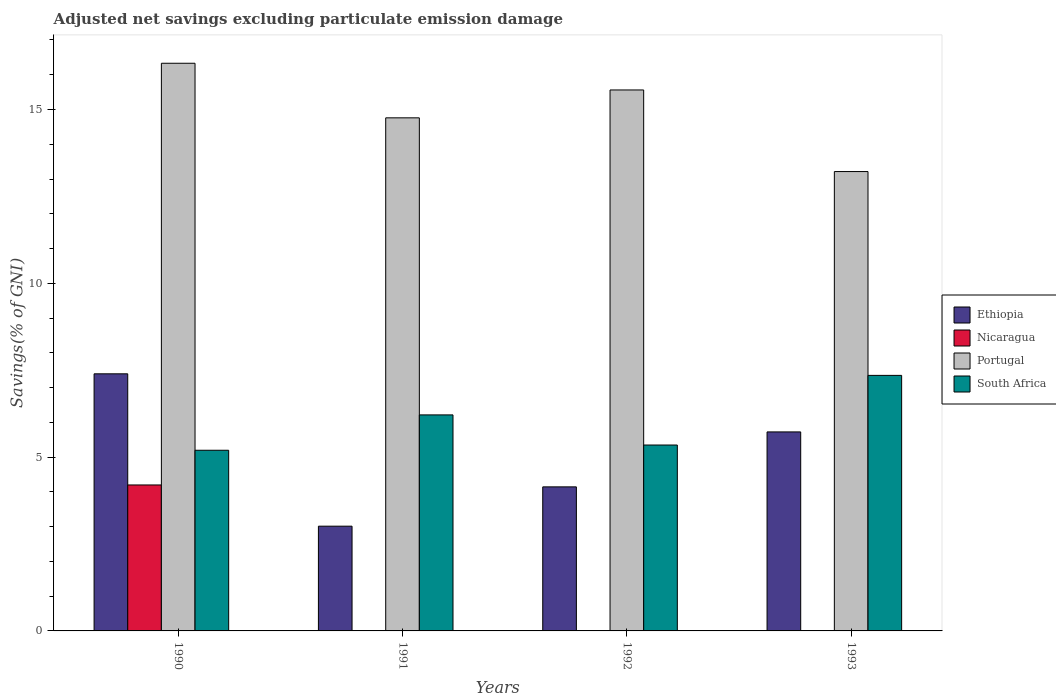How many groups of bars are there?
Make the answer very short. 4. How many bars are there on the 1st tick from the left?
Offer a very short reply. 4. What is the label of the 2nd group of bars from the left?
Ensure brevity in your answer.  1991. In how many cases, is the number of bars for a given year not equal to the number of legend labels?
Offer a terse response. 3. What is the adjusted net savings in Ethiopia in 1993?
Offer a very short reply. 5.72. Across all years, what is the maximum adjusted net savings in Portugal?
Make the answer very short. 16.33. Across all years, what is the minimum adjusted net savings in Portugal?
Offer a very short reply. 13.21. What is the total adjusted net savings in Nicaragua in the graph?
Offer a very short reply. 4.2. What is the difference between the adjusted net savings in Portugal in 1990 and that in 1993?
Provide a succinct answer. 3.12. What is the difference between the adjusted net savings in Nicaragua in 1993 and the adjusted net savings in South Africa in 1991?
Provide a short and direct response. -6.21. What is the average adjusted net savings in Nicaragua per year?
Give a very brief answer. 1.05. In the year 1990, what is the difference between the adjusted net savings in Nicaragua and adjusted net savings in Portugal?
Offer a very short reply. -12.13. What is the ratio of the adjusted net savings in Ethiopia in 1991 to that in 1993?
Your answer should be very brief. 0.53. What is the difference between the highest and the second highest adjusted net savings in Ethiopia?
Your answer should be very brief. 1.67. What is the difference between the highest and the lowest adjusted net savings in Ethiopia?
Ensure brevity in your answer.  4.38. Is it the case that in every year, the sum of the adjusted net savings in Nicaragua and adjusted net savings in South Africa is greater than the sum of adjusted net savings in Ethiopia and adjusted net savings in Portugal?
Keep it short and to the point. No. Is it the case that in every year, the sum of the adjusted net savings in South Africa and adjusted net savings in Portugal is greater than the adjusted net savings in Ethiopia?
Ensure brevity in your answer.  Yes. How many years are there in the graph?
Provide a short and direct response. 4. Are the values on the major ticks of Y-axis written in scientific E-notation?
Provide a short and direct response. No. Does the graph contain any zero values?
Give a very brief answer. Yes. Does the graph contain grids?
Give a very brief answer. No. How are the legend labels stacked?
Give a very brief answer. Vertical. What is the title of the graph?
Offer a terse response. Adjusted net savings excluding particulate emission damage. Does "Lebanon" appear as one of the legend labels in the graph?
Provide a short and direct response. No. What is the label or title of the Y-axis?
Your answer should be compact. Savings(% of GNI). What is the Savings(% of GNI) of Ethiopia in 1990?
Your response must be concise. 7.4. What is the Savings(% of GNI) of Nicaragua in 1990?
Your answer should be compact. 4.2. What is the Savings(% of GNI) in Portugal in 1990?
Offer a terse response. 16.33. What is the Savings(% of GNI) in South Africa in 1990?
Keep it short and to the point. 5.2. What is the Savings(% of GNI) in Ethiopia in 1991?
Provide a short and direct response. 3.01. What is the Savings(% of GNI) of Portugal in 1991?
Your answer should be compact. 14.76. What is the Savings(% of GNI) in South Africa in 1991?
Your response must be concise. 6.21. What is the Savings(% of GNI) of Ethiopia in 1992?
Make the answer very short. 4.14. What is the Savings(% of GNI) of Nicaragua in 1992?
Offer a very short reply. 0. What is the Savings(% of GNI) of Portugal in 1992?
Provide a succinct answer. 15.56. What is the Savings(% of GNI) of South Africa in 1992?
Make the answer very short. 5.35. What is the Savings(% of GNI) of Ethiopia in 1993?
Your answer should be very brief. 5.72. What is the Savings(% of GNI) in Portugal in 1993?
Make the answer very short. 13.21. What is the Savings(% of GNI) in South Africa in 1993?
Your response must be concise. 7.35. Across all years, what is the maximum Savings(% of GNI) in Ethiopia?
Your answer should be compact. 7.4. Across all years, what is the maximum Savings(% of GNI) in Nicaragua?
Give a very brief answer. 4.2. Across all years, what is the maximum Savings(% of GNI) of Portugal?
Provide a succinct answer. 16.33. Across all years, what is the maximum Savings(% of GNI) in South Africa?
Your answer should be compact. 7.35. Across all years, what is the minimum Savings(% of GNI) of Ethiopia?
Provide a succinct answer. 3.01. Across all years, what is the minimum Savings(% of GNI) of Nicaragua?
Offer a terse response. 0. Across all years, what is the minimum Savings(% of GNI) in Portugal?
Provide a succinct answer. 13.21. Across all years, what is the minimum Savings(% of GNI) in South Africa?
Your response must be concise. 5.2. What is the total Savings(% of GNI) in Ethiopia in the graph?
Keep it short and to the point. 20.28. What is the total Savings(% of GNI) in Nicaragua in the graph?
Your answer should be compact. 4.2. What is the total Savings(% of GNI) in Portugal in the graph?
Your answer should be compact. 59.87. What is the total Savings(% of GNI) in South Africa in the graph?
Offer a very short reply. 24.11. What is the difference between the Savings(% of GNI) in Ethiopia in 1990 and that in 1991?
Your answer should be compact. 4.38. What is the difference between the Savings(% of GNI) in Portugal in 1990 and that in 1991?
Offer a very short reply. 1.57. What is the difference between the Savings(% of GNI) of South Africa in 1990 and that in 1991?
Offer a very short reply. -1.02. What is the difference between the Savings(% of GNI) in Ethiopia in 1990 and that in 1992?
Ensure brevity in your answer.  3.25. What is the difference between the Savings(% of GNI) of Portugal in 1990 and that in 1992?
Keep it short and to the point. 0.77. What is the difference between the Savings(% of GNI) of South Africa in 1990 and that in 1992?
Make the answer very short. -0.15. What is the difference between the Savings(% of GNI) of Ethiopia in 1990 and that in 1993?
Your response must be concise. 1.67. What is the difference between the Savings(% of GNI) of Portugal in 1990 and that in 1993?
Offer a terse response. 3.12. What is the difference between the Savings(% of GNI) in South Africa in 1990 and that in 1993?
Make the answer very short. -2.15. What is the difference between the Savings(% of GNI) of Ethiopia in 1991 and that in 1992?
Provide a succinct answer. -1.13. What is the difference between the Savings(% of GNI) in Portugal in 1991 and that in 1992?
Your answer should be very brief. -0.8. What is the difference between the Savings(% of GNI) of South Africa in 1991 and that in 1992?
Your response must be concise. 0.87. What is the difference between the Savings(% of GNI) in Ethiopia in 1991 and that in 1993?
Your response must be concise. -2.71. What is the difference between the Savings(% of GNI) in Portugal in 1991 and that in 1993?
Your answer should be compact. 1.55. What is the difference between the Savings(% of GNI) in South Africa in 1991 and that in 1993?
Offer a terse response. -1.14. What is the difference between the Savings(% of GNI) in Ethiopia in 1992 and that in 1993?
Provide a succinct answer. -1.58. What is the difference between the Savings(% of GNI) of Portugal in 1992 and that in 1993?
Give a very brief answer. 2.35. What is the difference between the Savings(% of GNI) in South Africa in 1992 and that in 1993?
Make the answer very short. -2. What is the difference between the Savings(% of GNI) in Ethiopia in 1990 and the Savings(% of GNI) in Portugal in 1991?
Give a very brief answer. -7.36. What is the difference between the Savings(% of GNI) of Ethiopia in 1990 and the Savings(% of GNI) of South Africa in 1991?
Provide a short and direct response. 1.18. What is the difference between the Savings(% of GNI) of Nicaragua in 1990 and the Savings(% of GNI) of Portugal in 1991?
Make the answer very short. -10.56. What is the difference between the Savings(% of GNI) in Nicaragua in 1990 and the Savings(% of GNI) in South Africa in 1991?
Provide a succinct answer. -2.02. What is the difference between the Savings(% of GNI) of Portugal in 1990 and the Savings(% of GNI) of South Africa in 1991?
Keep it short and to the point. 10.12. What is the difference between the Savings(% of GNI) of Ethiopia in 1990 and the Savings(% of GNI) of Portugal in 1992?
Give a very brief answer. -8.17. What is the difference between the Savings(% of GNI) of Ethiopia in 1990 and the Savings(% of GNI) of South Africa in 1992?
Offer a very short reply. 2.05. What is the difference between the Savings(% of GNI) in Nicaragua in 1990 and the Savings(% of GNI) in Portugal in 1992?
Make the answer very short. -11.36. What is the difference between the Savings(% of GNI) of Nicaragua in 1990 and the Savings(% of GNI) of South Africa in 1992?
Offer a terse response. -1.15. What is the difference between the Savings(% of GNI) of Portugal in 1990 and the Savings(% of GNI) of South Africa in 1992?
Give a very brief answer. 10.98. What is the difference between the Savings(% of GNI) of Ethiopia in 1990 and the Savings(% of GNI) of Portugal in 1993?
Offer a very short reply. -5.82. What is the difference between the Savings(% of GNI) in Ethiopia in 1990 and the Savings(% of GNI) in South Africa in 1993?
Keep it short and to the point. 0.04. What is the difference between the Savings(% of GNI) of Nicaragua in 1990 and the Savings(% of GNI) of Portugal in 1993?
Your response must be concise. -9.02. What is the difference between the Savings(% of GNI) of Nicaragua in 1990 and the Savings(% of GNI) of South Africa in 1993?
Make the answer very short. -3.15. What is the difference between the Savings(% of GNI) of Portugal in 1990 and the Savings(% of GNI) of South Africa in 1993?
Give a very brief answer. 8.98. What is the difference between the Savings(% of GNI) of Ethiopia in 1991 and the Savings(% of GNI) of Portugal in 1992?
Offer a terse response. -12.55. What is the difference between the Savings(% of GNI) in Ethiopia in 1991 and the Savings(% of GNI) in South Africa in 1992?
Provide a short and direct response. -2.33. What is the difference between the Savings(% of GNI) in Portugal in 1991 and the Savings(% of GNI) in South Africa in 1992?
Your answer should be compact. 9.41. What is the difference between the Savings(% of GNI) of Ethiopia in 1991 and the Savings(% of GNI) of Portugal in 1993?
Keep it short and to the point. -10.2. What is the difference between the Savings(% of GNI) in Ethiopia in 1991 and the Savings(% of GNI) in South Africa in 1993?
Your response must be concise. -4.34. What is the difference between the Savings(% of GNI) of Portugal in 1991 and the Savings(% of GNI) of South Africa in 1993?
Ensure brevity in your answer.  7.41. What is the difference between the Savings(% of GNI) in Ethiopia in 1992 and the Savings(% of GNI) in Portugal in 1993?
Keep it short and to the point. -9.07. What is the difference between the Savings(% of GNI) of Ethiopia in 1992 and the Savings(% of GNI) of South Africa in 1993?
Offer a very short reply. -3.21. What is the difference between the Savings(% of GNI) in Portugal in 1992 and the Savings(% of GNI) in South Africa in 1993?
Offer a very short reply. 8.21. What is the average Savings(% of GNI) of Ethiopia per year?
Ensure brevity in your answer.  5.07. What is the average Savings(% of GNI) of Nicaragua per year?
Ensure brevity in your answer.  1.05. What is the average Savings(% of GNI) of Portugal per year?
Give a very brief answer. 14.97. What is the average Savings(% of GNI) in South Africa per year?
Offer a very short reply. 6.03. In the year 1990, what is the difference between the Savings(% of GNI) of Ethiopia and Savings(% of GNI) of Nicaragua?
Ensure brevity in your answer.  3.2. In the year 1990, what is the difference between the Savings(% of GNI) in Ethiopia and Savings(% of GNI) in Portugal?
Keep it short and to the point. -8.93. In the year 1990, what is the difference between the Savings(% of GNI) in Ethiopia and Savings(% of GNI) in South Africa?
Provide a short and direct response. 2.2. In the year 1990, what is the difference between the Savings(% of GNI) of Nicaragua and Savings(% of GNI) of Portugal?
Ensure brevity in your answer.  -12.13. In the year 1990, what is the difference between the Savings(% of GNI) of Nicaragua and Savings(% of GNI) of South Africa?
Your answer should be compact. -1. In the year 1990, what is the difference between the Savings(% of GNI) of Portugal and Savings(% of GNI) of South Africa?
Your answer should be very brief. 11.13. In the year 1991, what is the difference between the Savings(% of GNI) of Ethiopia and Savings(% of GNI) of Portugal?
Offer a terse response. -11.75. In the year 1991, what is the difference between the Savings(% of GNI) in Ethiopia and Savings(% of GNI) in South Africa?
Offer a terse response. -3.2. In the year 1991, what is the difference between the Savings(% of GNI) in Portugal and Savings(% of GNI) in South Africa?
Your answer should be very brief. 8.55. In the year 1992, what is the difference between the Savings(% of GNI) of Ethiopia and Savings(% of GNI) of Portugal?
Your response must be concise. -11.42. In the year 1992, what is the difference between the Savings(% of GNI) in Ethiopia and Savings(% of GNI) in South Africa?
Your answer should be very brief. -1.2. In the year 1992, what is the difference between the Savings(% of GNI) in Portugal and Savings(% of GNI) in South Africa?
Make the answer very short. 10.21. In the year 1993, what is the difference between the Savings(% of GNI) of Ethiopia and Savings(% of GNI) of Portugal?
Offer a very short reply. -7.49. In the year 1993, what is the difference between the Savings(% of GNI) in Ethiopia and Savings(% of GNI) in South Africa?
Give a very brief answer. -1.63. In the year 1993, what is the difference between the Savings(% of GNI) in Portugal and Savings(% of GNI) in South Africa?
Your answer should be very brief. 5.86. What is the ratio of the Savings(% of GNI) in Ethiopia in 1990 to that in 1991?
Your response must be concise. 2.45. What is the ratio of the Savings(% of GNI) of Portugal in 1990 to that in 1991?
Keep it short and to the point. 1.11. What is the ratio of the Savings(% of GNI) of South Africa in 1990 to that in 1991?
Provide a short and direct response. 0.84. What is the ratio of the Savings(% of GNI) of Ethiopia in 1990 to that in 1992?
Make the answer very short. 1.78. What is the ratio of the Savings(% of GNI) in Portugal in 1990 to that in 1992?
Your answer should be compact. 1.05. What is the ratio of the Savings(% of GNI) of South Africa in 1990 to that in 1992?
Keep it short and to the point. 0.97. What is the ratio of the Savings(% of GNI) in Ethiopia in 1990 to that in 1993?
Your answer should be very brief. 1.29. What is the ratio of the Savings(% of GNI) in Portugal in 1990 to that in 1993?
Your answer should be compact. 1.24. What is the ratio of the Savings(% of GNI) in South Africa in 1990 to that in 1993?
Provide a short and direct response. 0.71. What is the ratio of the Savings(% of GNI) in Ethiopia in 1991 to that in 1992?
Keep it short and to the point. 0.73. What is the ratio of the Savings(% of GNI) of Portugal in 1991 to that in 1992?
Keep it short and to the point. 0.95. What is the ratio of the Savings(% of GNI) of South Africa in 1991 to that in 1992?
Make the answer very short. 1.16. What is the ratio of the Savings(% of GNI) of Ethiopia in 1991 to that in 1993?
Make the answer very short. 0.53. What is the ratio of the Savings(% of GNI) in Portugal in 1991 to that in 1993?
Offer a very short reply. 1.12. What is the ratio of the Savings(% of GNI) of South Africa in 1991 to that in 1993?
Give a very brief answer. 0.85. What is the ratio of the Savings(% of GNI) in Ethiopia in 1992 to that in 1993?
Ensure brevity in your answer.  0.72. What is the ratio of the Savings(% of GNI) of Portugal in 1992 to that in 1993?
Your response must be concise. 1.18. What is the ratio of the Savings(% of GNI) in South Africa in 1992 to that in 1993?
Make the answer very short. 0.73. What is the difference between the highest and the second highest Savings(% of GNI) of Ethiopia?
Provide a short and direct response. 1.67. What is the difference between the highest and the second highest Savings(% of GNI) of Portugal?
Keep it short and to the point. 0.77. What is the difference between the highest and the second highest Savings(% of GNI) of South Africa?
Ensure brevity in your answer.  1.14. What is the difference between the highest and the lowest Savings(% of GNI) in Ethiopia?
Make the answer very short. 4.38. What is the difference between the highest and the lowest Savings(% of GNI) of Nicaragua?
Your answer should be compact. 4.2. What is the difference between the highest and the lowest Savings(% of GNI) in Portugal?
Offer a terse response. 3.12. What is the difference between the highest and the lowest Savings(% of GNI) of South Africa?
Make the answer very short. 2.15. 